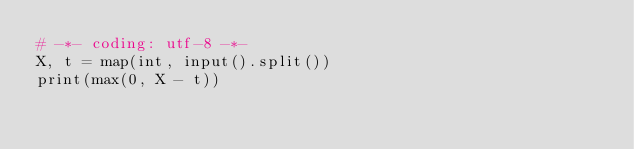<code> <loc_0><loc_0><loc_500><loc_500><_Python_># -*- coding: utf-8 -*-
X, t = map(int, input().split())
print(max(0, X - t))
</code> 